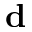<formula> <loc_0><loc_0><loc_500><loc_500>{ d }</formula> 